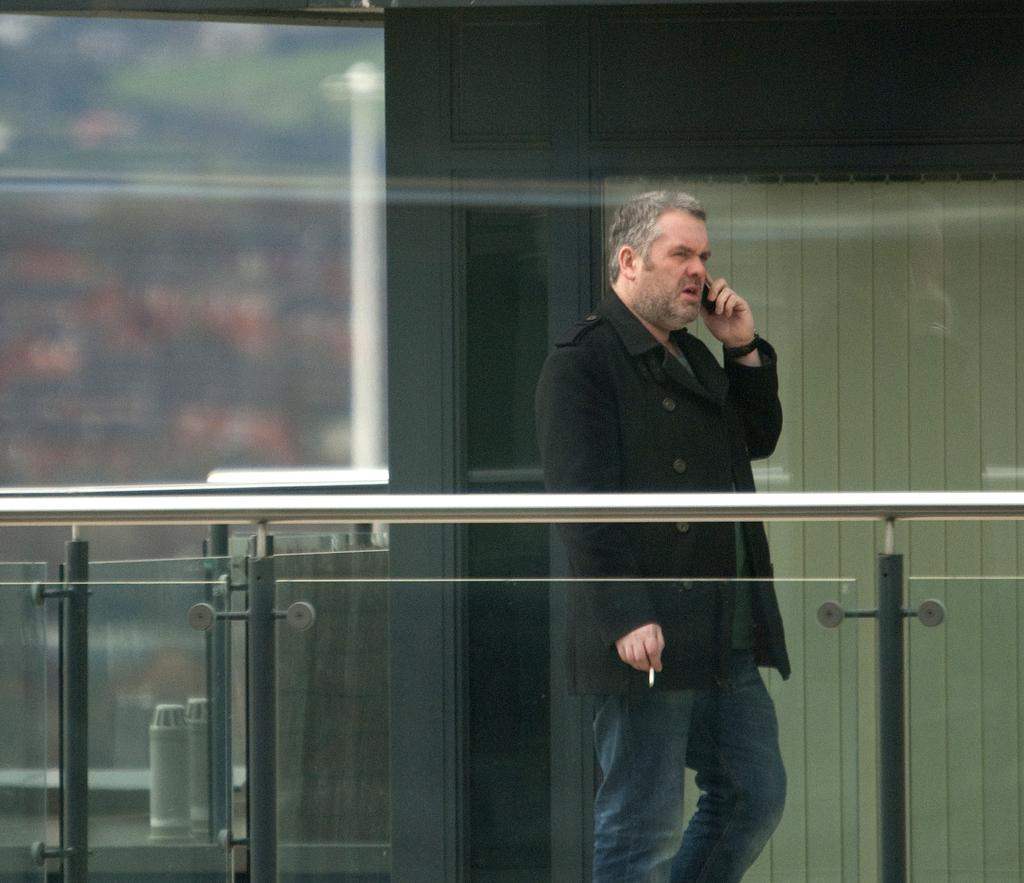Who is present in the image? There is a man in the image. What is the man holding in the image? The man is holding a mobile and a cigarette. What can be seen in the background of the image? There are curtains and pipes in the background of the image. What type of corn is being painted by the judge in the image? There is no judge or corn present in the image. What color is the paint being used by the judge to paint the corn in the image? There is no judge, corn, or paint present in the image. 